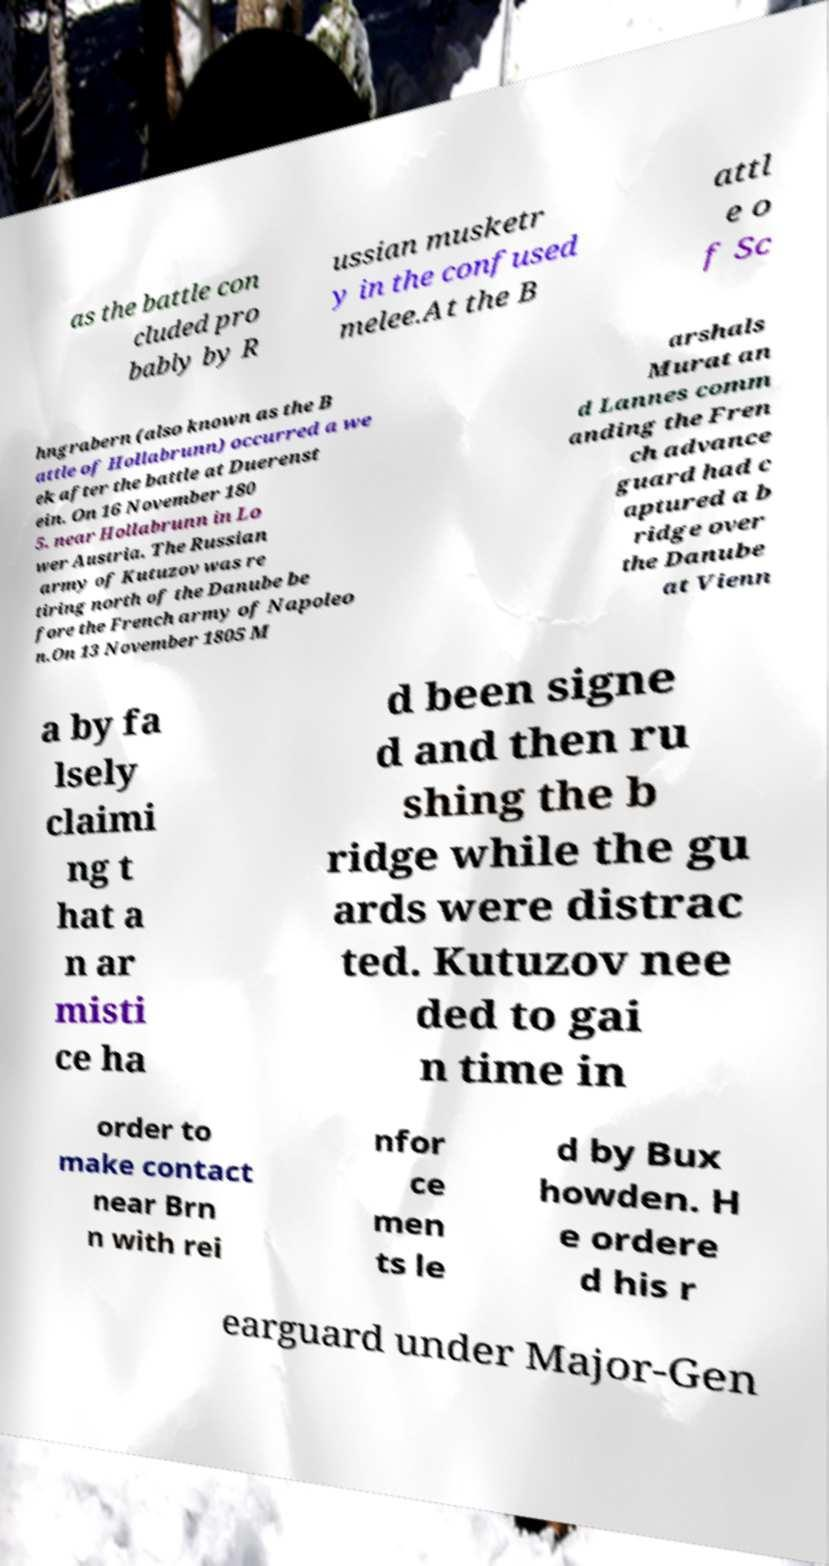I need the written content from this picture converted into text. Can you do that? as the battle con cluded pro bably by R ussian musketr y in the confused melee.At the B attl e o f Sc hngrabern (also known as the B attle of Hollabrunn) occurred a we ek after the battle at Duerenst ein. On 16 November 180 5. near Hollabrunn in Lo wer Austria. The Russian army of Kutuzov was re tiring north of the Danube be fore the French army of Napoleo n.On 13 November 1805 M arshals Murat an d Lannes comm anding the Fren ch advance guard had c aptured a b ridge over the Danube at Vienn a by fa lsely claimi ng t hat a n ar misti ce ha d been signe d and then ru shing the b ridge while the gu ards were distrac ted. Kutuzov nee ded to gai n time in order to make contact near Brn n with rei nfor ce men ts le d by Bux howden. H e ordere d his r earguard under Major-Gen 